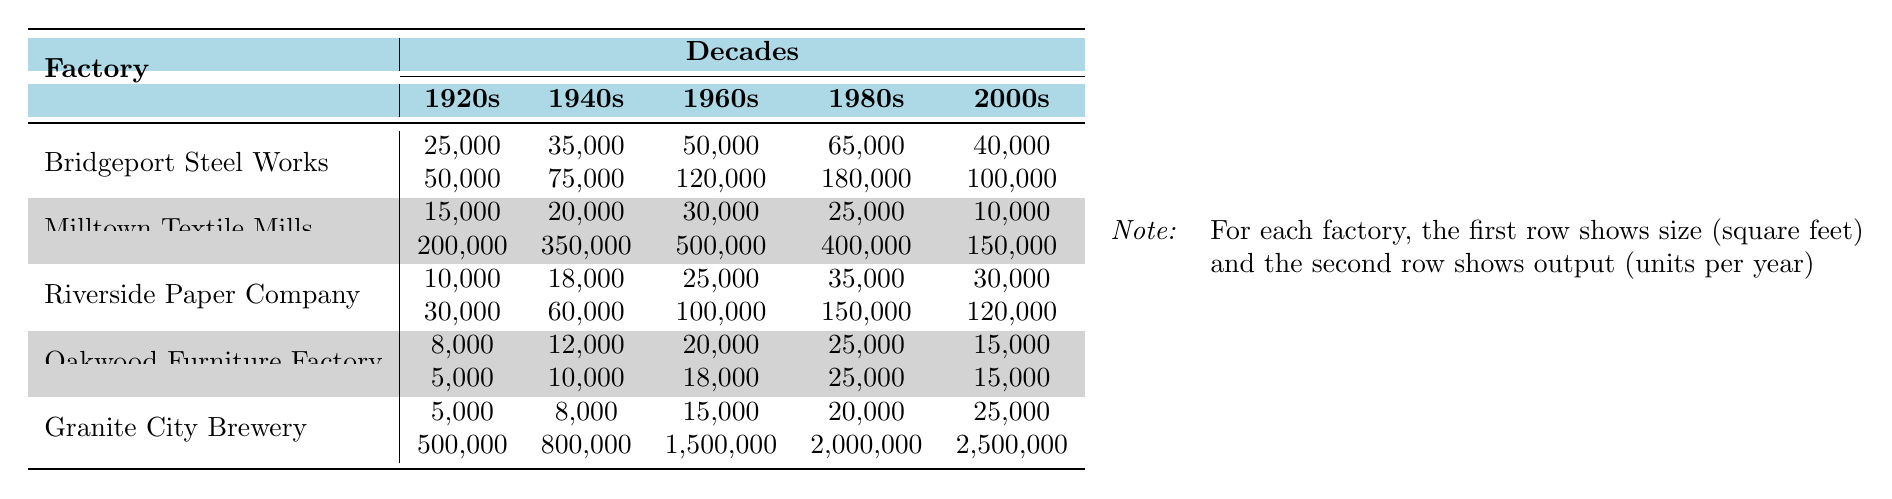What is the size of the Bridgeport Steel Works in the 1960s? From the table, we can see that the size of the Bridgeport Steel Works in the 1960s is listed as 50,000 square feet.
Answer: 50,000 square feet Which factory had the highest output in the 2000s? Looking at the outputs for the year 2000s, Granite City Brewery had an output of 2,500,000 units, which is higher than any other factory listed.
Answer: Granite City Brewery What was the output of the Oakwood Furniture Factory in the 1980s? Referring to the outputs for Oakwood Furniture Factory in the 1980s, it shows an output of 25,000 units per year.
Answer: 25,000 units What is the average size of the Milltown Textile Mills across all decades? Summing the sizes: 15,000 + 20,000 + 30,000 + 25,000 + 10,000 = 100,000 square feet. There are 5 data points, so average size = 100,000 / 5 = 20,000 square feet.
Answer: 20,000 square feet Did the size of Riverside Paper Company increase from the 1940s to the 1960s? The sizes for Riverside Paper Company are 18,000 square feet in the 1940s and 25,000 square feet in the 1960s. Since 25,000 is greater than 18,000, the size did increase.
Answer: Yes What was the total output of the Granite City Brewery from the 1920s to the 2000s? Adding the outputs: 500,000 + 800,000 + 1,500,000 + 2,000,000 + 2,500,000 = 7,300,000 units.
Answer: 7,300,000 units Which factory maintained the lowest output throughout all decades? Observing the outputs, Oakwood Furniture Factory consistently had the lowest outputs across all decades compared to the others, with a maximum of 25,000 units in the 1980s.
Answer: Oakwood Furniture Factory Calculate the percentage increase in output for Bridgeport Steel Works from the 1940s to the 1960s. The output in the 1940s was 75,000 and in the 1960s it was 120,000. The increase = 120,000 - 75,000 = 45,000. The percentage increase = (45,000 / 75,000) × 100 = 60%.
Answer: 60% What is the difference in size between the largest and smallest factory in the 1980s? The largest factory size in 1980s is Bridgeport Steel Works at 65,000 square feet, and the smallest is Oakwood Furniture Factory at 25,000 square feet. The difference = 65,000 - 25,000 = 40,000 square feet.
Answer: 40,000 square feet How many factories had an output greater than 150,000 units in the 1960s? Looking at the outputs for the 1960s: Milltown Textile Mills (500,000), Granite City Brewery (1,500,000), and Bridgeport Steel Works (120,000) are above 150,000, giving us a total of 2 factories.
Answer: 2 factories 